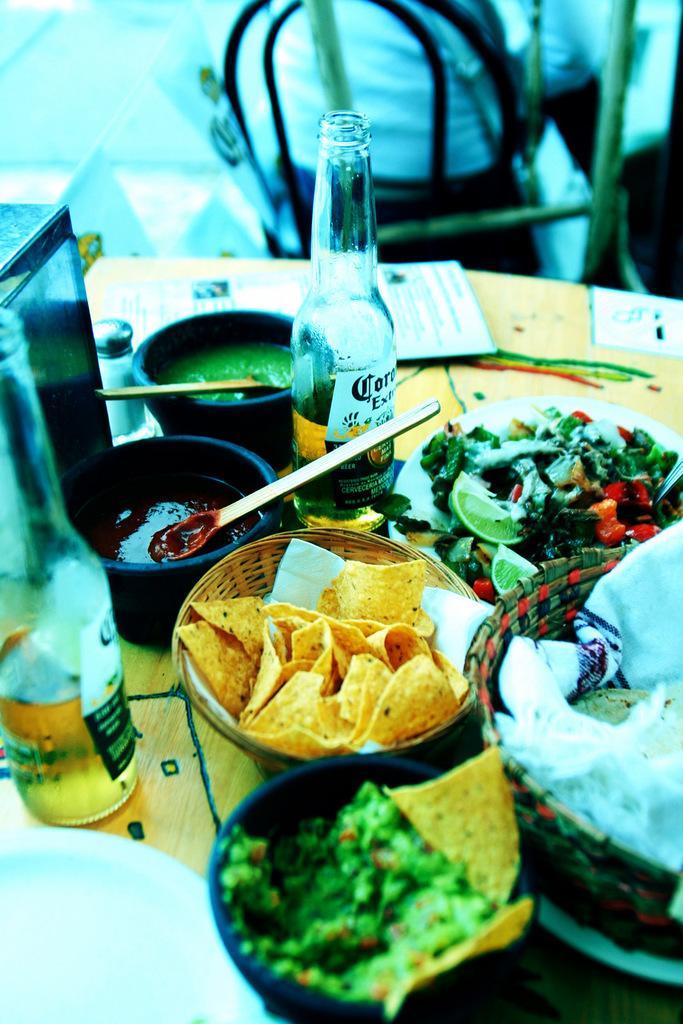How would you summarize this image in a sentence or two? This is the picture of a table on which some bowls and bottles are placed. 